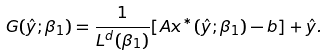<formula> <loc_0><loc_0><loc_500><loc_500>G ( \hat { y } ; \beta _ { 1 } ) = \frac { 1 } { L ^ { d } ( \beta _ { 1 } ) } [ A x ^ { * } ( \hat { y } ; \beta _ { 1 } ) - b ] + \hat { y } .</formula> 